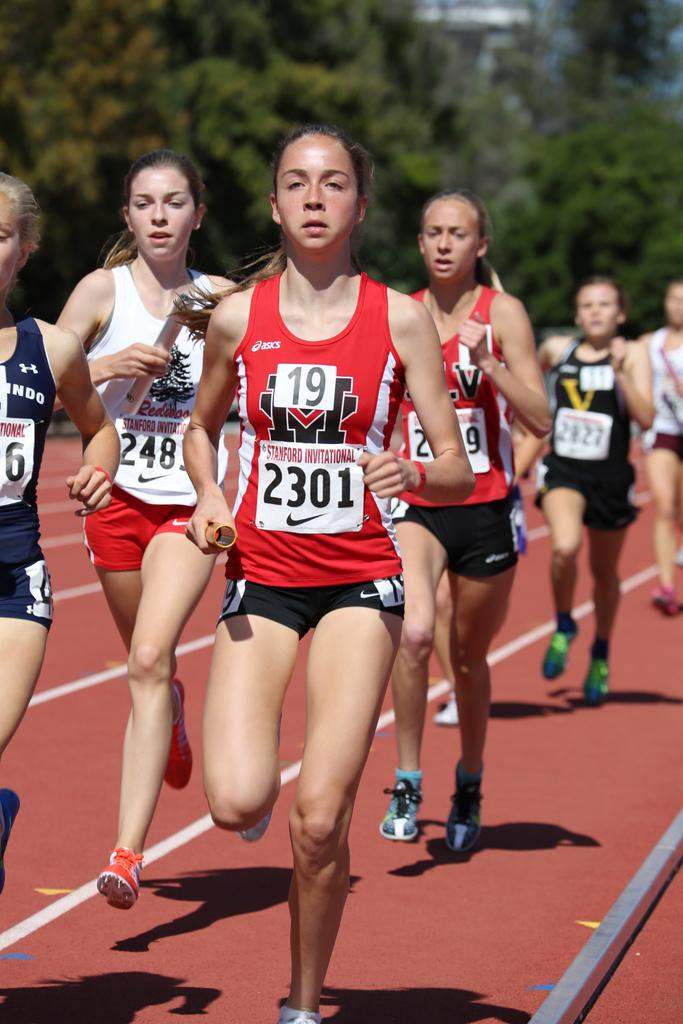<image>
Provide a brief description of the given image. A woman is running with the number 19 on her chest. 